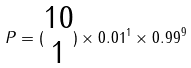<formula> <loc_0><loc_0><loc_500><loc_500>P = ( \begin{matrix} 1 0 \\ 1 \end{matrix} ) \times 0 . 0 1 ^ { 1 } \times 0 . 9 9 ^ { 9 }</formula> 